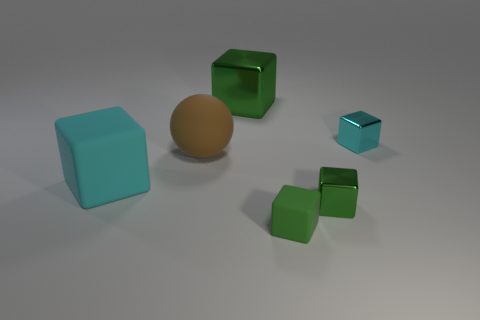Do the large brown sphere and the small green block to the right of the green rubber thing have the same material?
Your answer should be compact. No. What number of things are cyan things that are to the left of the cyan shiny block or cyan objects right of the small rubber thing?
Make the answer very short. 2. The large rubber ball is what color?
Provide a short and direct response. Brown. Are there fewer tiny green things that are behind the brown object than big brown things?
Offer a very short reply. Yes. Is there anything else that is the same shape as the cyan matte object?
Make the answer very short. Yes. Are there any tiny purple rubber things?
Ensure brevity in your answer.  No. Are there fewer tiny cyan blocks than red cylinders?
Provide a succinct answer. No. What number of large blue cylinders have the same material as the tiny cyan block?
Provide a short and direct response. 0. What color is the large sphere that is made of the same material as the big cyan cube?
Keep it short and to the point. Brown. The small cyan metal object has what shape?
Give a very brief answer. Cube. 